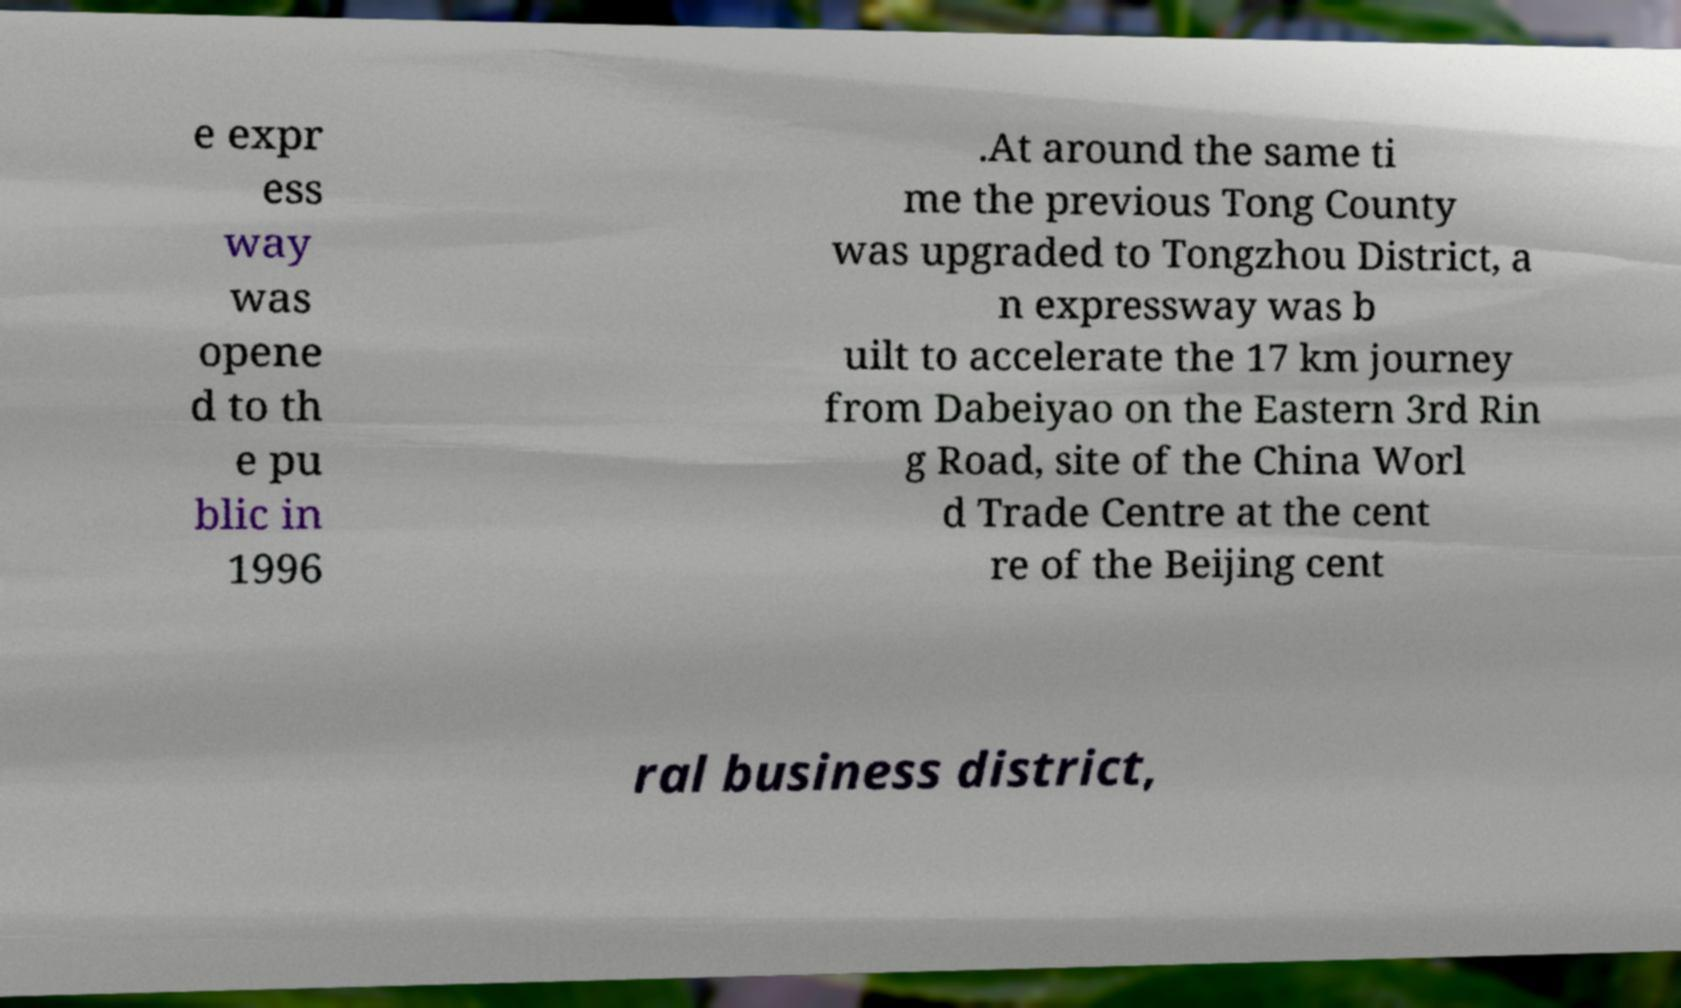I need the written content from this picture converted into text. Can you do that? e expr ess way was opene d to th e pu blic in 1996 .At around the same ti me the previous Tong County was upgraded to Tongzhou District, a n expressway was b uilt to accelerate the 17 km journey from Dabeiyao on the Eastern 3rd Rin g Road, site of the China Worl d Trade Centre at the cent re of the Beijing cent ral business district, 